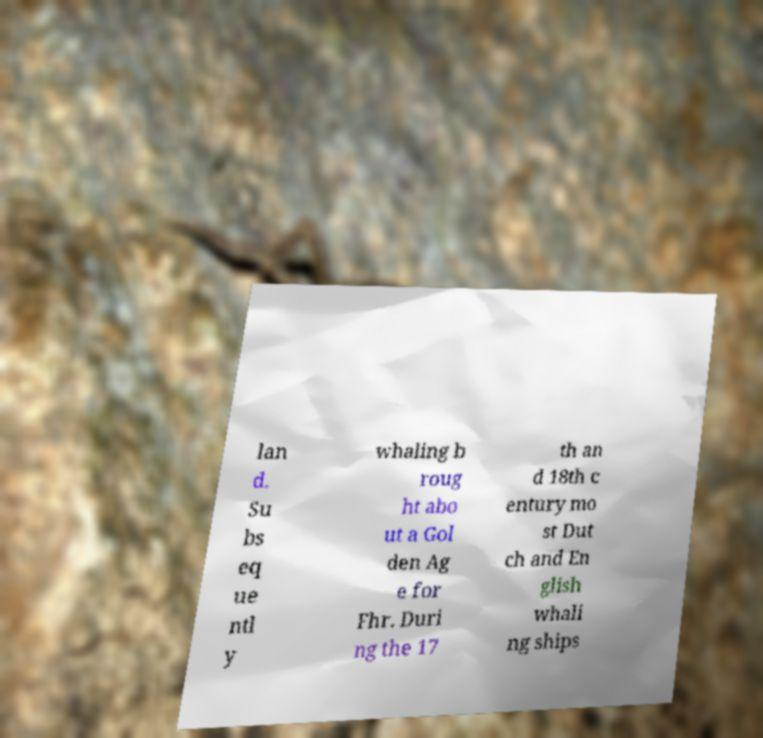Could you extract and type out the text from this image? lan d. Su bs eq ue ntl y whaling b roug ht abo ut a Gol den Ag e for Fhr. Duri ng the 17 th an d 18th c entury mo st Dut ch and En glish whali ng ships 